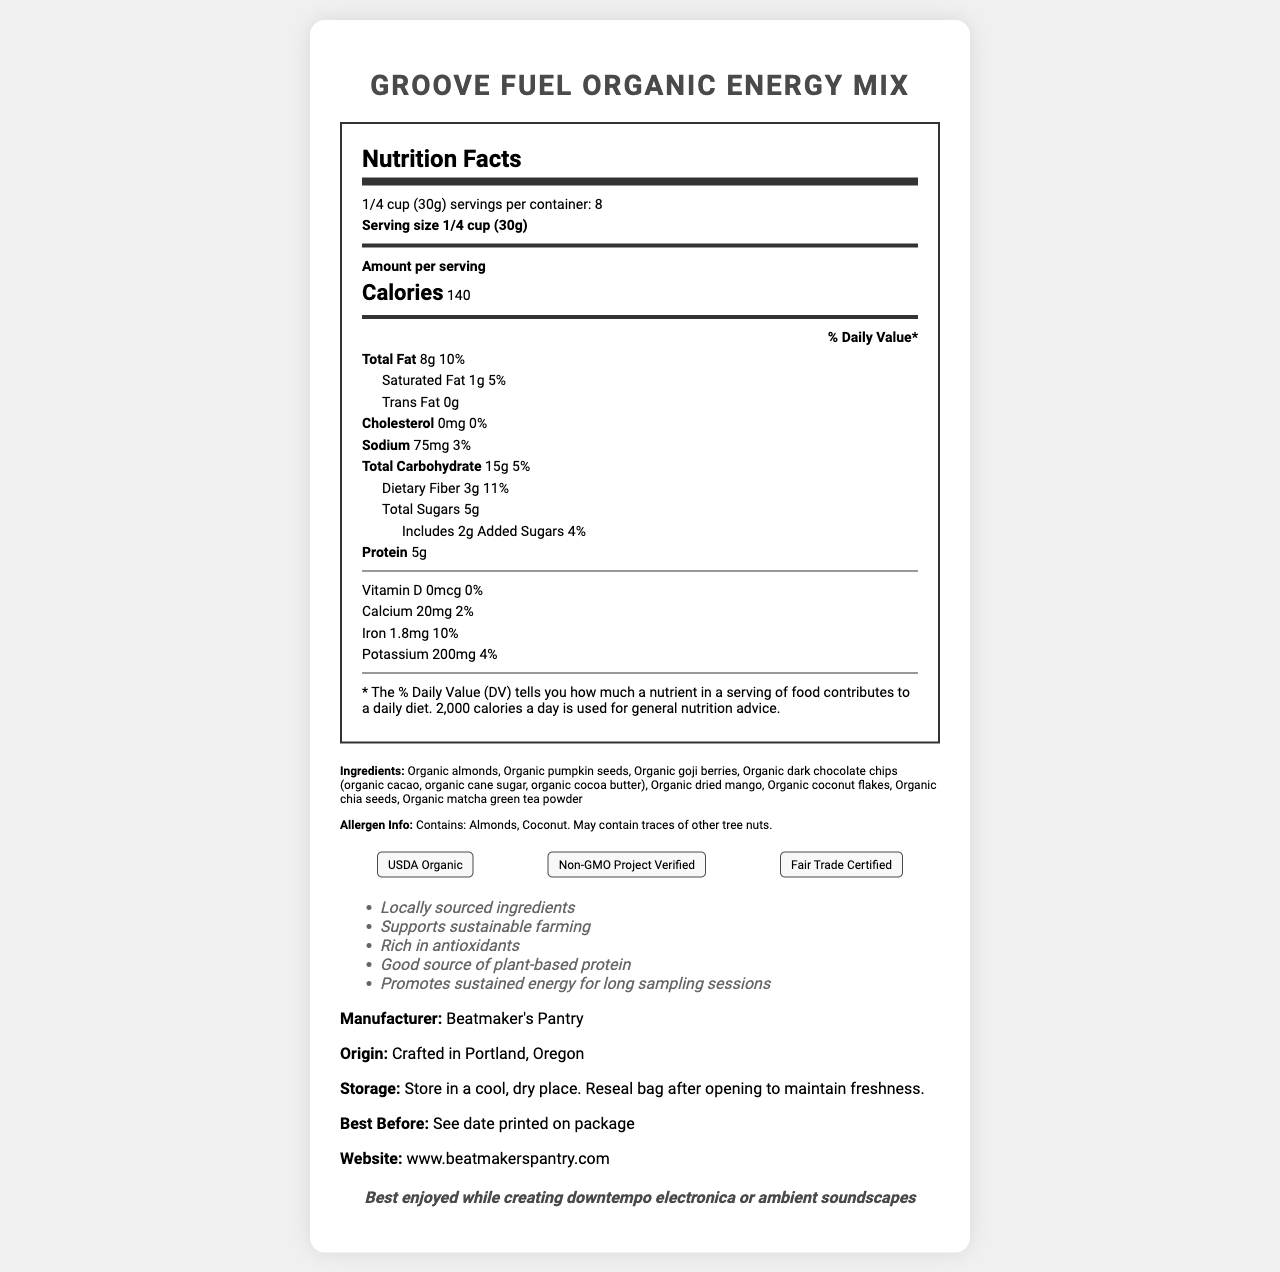what is the serving size of Groove Fuel Organic Energy Mix? The serving size is explicitly stated in the Nutrition Facts section as "1/4 cup (30g)".
Answer: 1/4 cup (30g) how many calories are in one serving? The Nutrition Facts section states that each serving contains 140 calories.
Answer: 140 which ingredients are highlighted in the allergen info? The Allergen Info section specifically mentions that the product contains Almonds and Coconut.
Answer: Almonds, Coconut How many grams of protein are in each serving? The Nutrition Facts section lists the protein content as 5g per serving.
Answer: 5g name two certifications that the product has. The Certifications section lists USDA Organic and Non-GMO Project Verified among others.
Answer: USDA Organic and Non-GMO Project Verified how does this product support sustained energy for long sampling sessions? The product claim explicitly mentioned that it promotes sustained energy for long sampling sessions.
Answer: Promotes sustained energy for long sampling sessions what is the dietary fiber content per serving? The Nutrition Facts section lists 3g of dietary fiber per serving.
Answer: 3g which of the following is a claim made about this product? A. Boosts immunity B. Good source of antioxidants C. Contains no sugar One of the product claims is "Rich in antioxidants".
Answer: B. Good source of antioxidants how many servings are there in one container? A. 6 B. 8 C. 10 D. 12 The document states that there are 8 servings per container.
Answer: B. 8 does this product contain any added sugars? The Nutrition Facts section shows that the product includes 2g of added sugars.
Answer: Yes does the product contain Vitamin D? According to the Nutrition Facts section, the Vitamin D content is 0mcg which means it does not contain Vitamin D.
Answer: No Summarize the main idea of the document. The document serves as a comprehensive guide to understanding the nutritional benefits, sourcing, and intended use of the "Groove Fuel Organic Energy Mix."
Answer: The document provides detailed nutritional information for "Groove Fuel Organic Energy Mix", an organic, locally-sourced snack designed to fuel creativity during sampling sessions. It highlights the serving size, calories, nutritional content, ingredients, allergen information, certifications, product claims, manufacturer information, origin, storage instructions, best before date, website, and music pairing suggestion. where is the product crafted? The document mentions that the product is crafted in Portland, Oregon.
Answer: Portland, Oregon what do the music pairing suggestions advise this snack is best enjoyed with? The music pairing suggestion explicitly advises that the snack is best enjoyed while creating downtempo electronica or ambient soundscapes.
Answer: While creating downtempo electronica or ambient soundscapes how much iron is present in one serving of the snack? The amount of iron per serving is listed as 1.8mg in the Nutrition Facts section.
Answer: 1.8mg What percentage of daily value of calcium does one serving provide? The Nutrition Facts section indicates that one serving provides 2% of the daily value for calcium.
Answer: 2% what is the official website for Beatmaker’s Pantry? The document lists www.beatmakerspantry.com as the official website.
Answer: www.beatmakerspantry.com What is the best before date of the product? The document states "See date printed on package" for the best before date; thus, it cannot be determined from the visual information provided.
Answer: Cannot be determined 